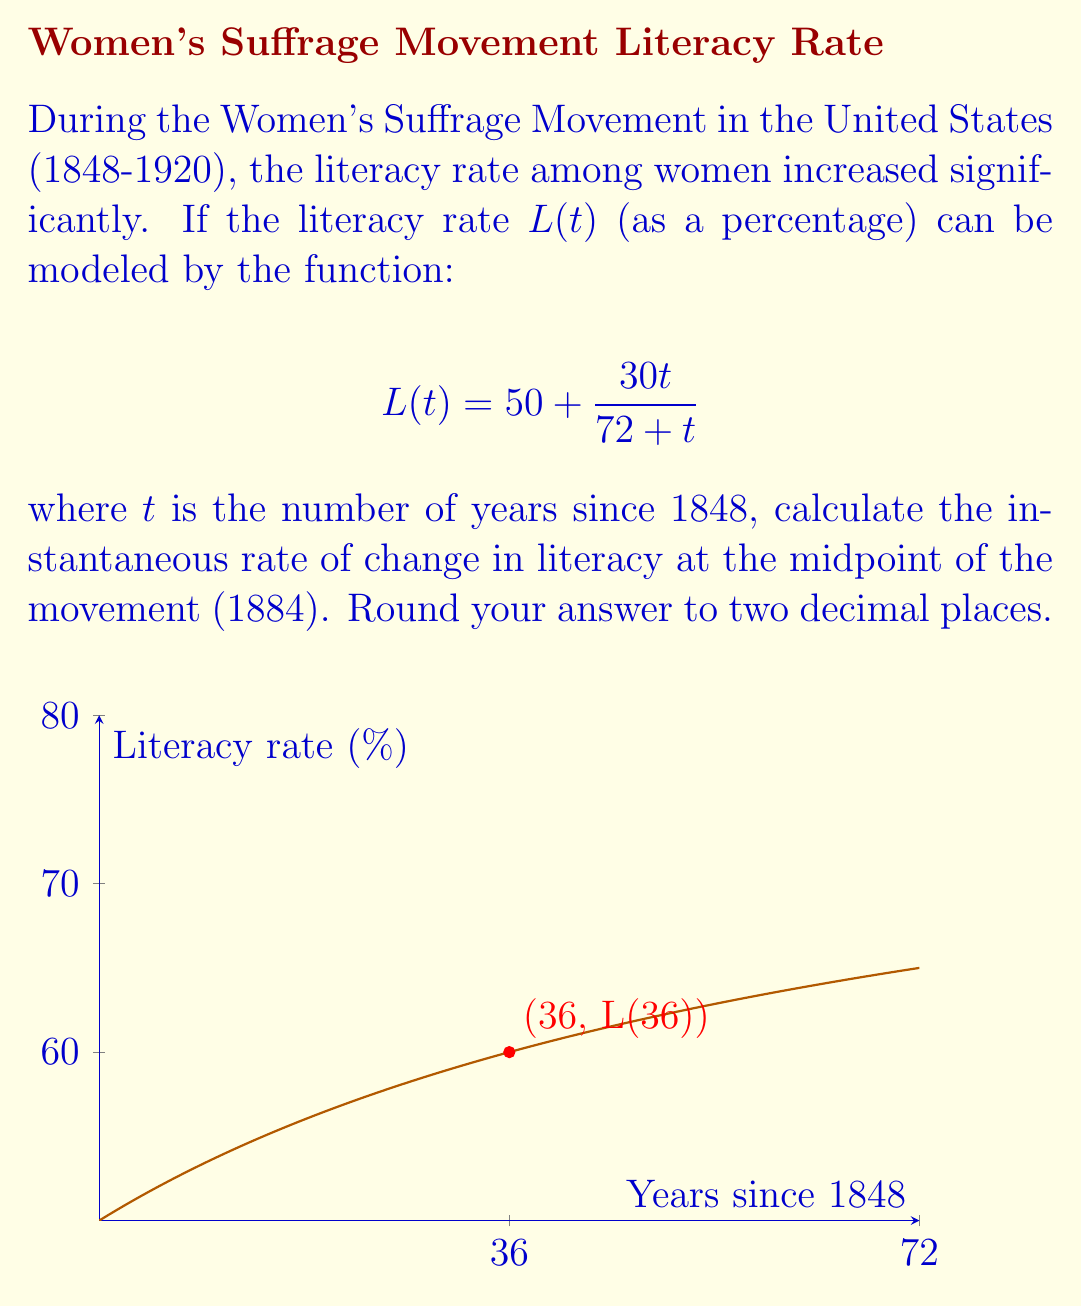Show me your answer to this math problem. To find the instantaneous rate of change, we need to calculate the derivative of $L(t)$ and evaluate it at $t=36$ (1884 is 36 years after 1848).

1) First, let's find $L'(t)$ using the quotient rule:
   $$L'(t) = \frac{d}{dt}\left(50 + \frac{30t}{72 + t}\right) = \frac{d}{dt}\left(\frac{30t}{72 + t}\right)$$
   $$L'(t) = \frac{30(72 + t) - 30t \cdot 1}{(72 + t)^2} = \frac{2160}{(72 + t)^2}$$

2) Now, we evaluate $L'(36)$:
   $$L'(36) = \frac{2160}{(72 + 36)^2} = \frac{2160}{108^2} = \frac{2160}{11664}$$

3) Simplify and round to two decimal places:
   $$L'(36) \approx 0.1852 \approx 0.19$$

This means that in 1884, the literacy rate was increasing at approximately 0.19 percentage points per year.
Answer: $0.19$ percentage points per year 